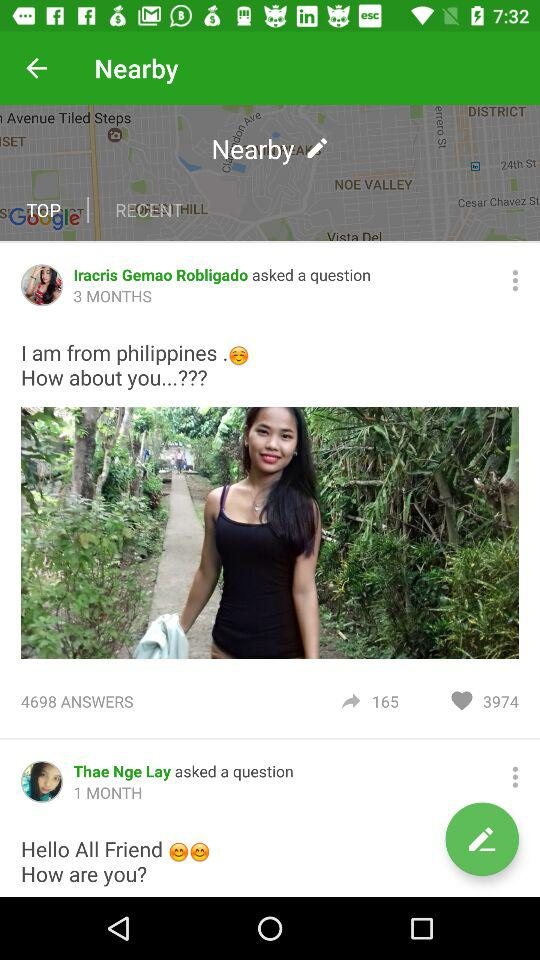How many shares are there of the "Iracris Gemao Robligado" post? There are 165 shares. 